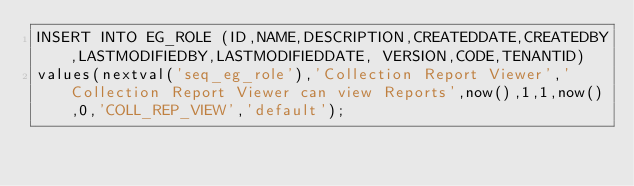Convert code to text. <code><loc_0><loc_0><loc_500><loc_500><_SQL_>INSERT INTO EG_ROLE (ID,NAME,DESCRIPTION,CREATEDDATE,CREATEDBY,LASTMODIFIEDBY,LASTMODIFIEDDATE,	VERSION,CODE,TENANTID) 
values(nextval('seq_eg_role'),'Collection Report Viewer','Collection Report Viewer can view Reports',now(),1,1,now(),0,'COLL_REP_VIEW','default');

</code> 